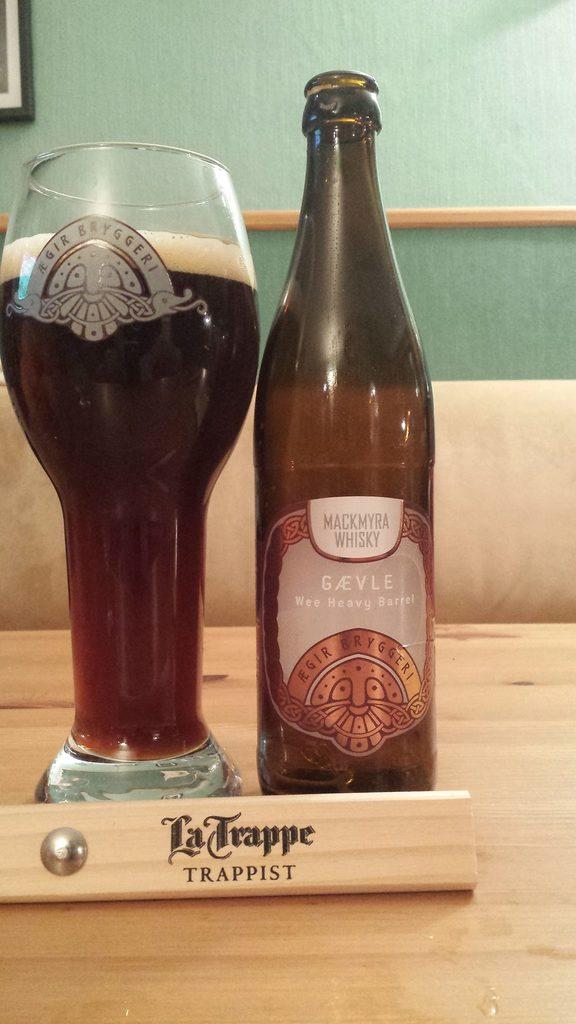<image>
Provide a brief description of the given image. A glass of beer sitting next to a bottle that is behind a sign that says Trappist. 